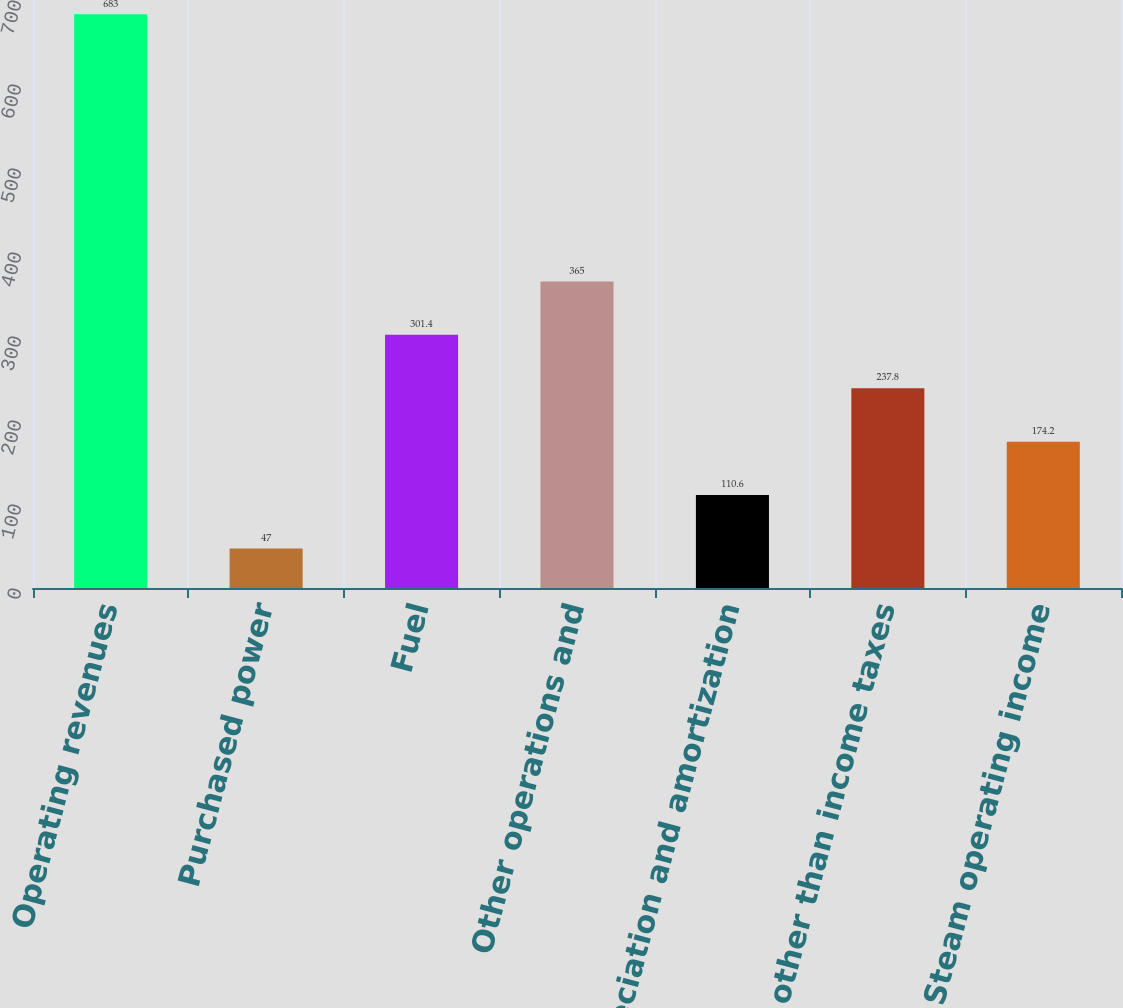Convert chart to OTSL. <chart><loc_0><loc_0><loc_500><loc_500><bar_chart><fcel>Operating revenues<fcel>Purchased power<fcel>Fuel<fcel>Other operations and<fcel>Depreciation and amortization<fcel>Taxes other than income taxes<fcel>Steam operating income<nl><fcel>683<fcel>47<fcel>301.4<fcel>365<fcel>110.6<fcel>237.8<fcel>174.2<nl></chart> 